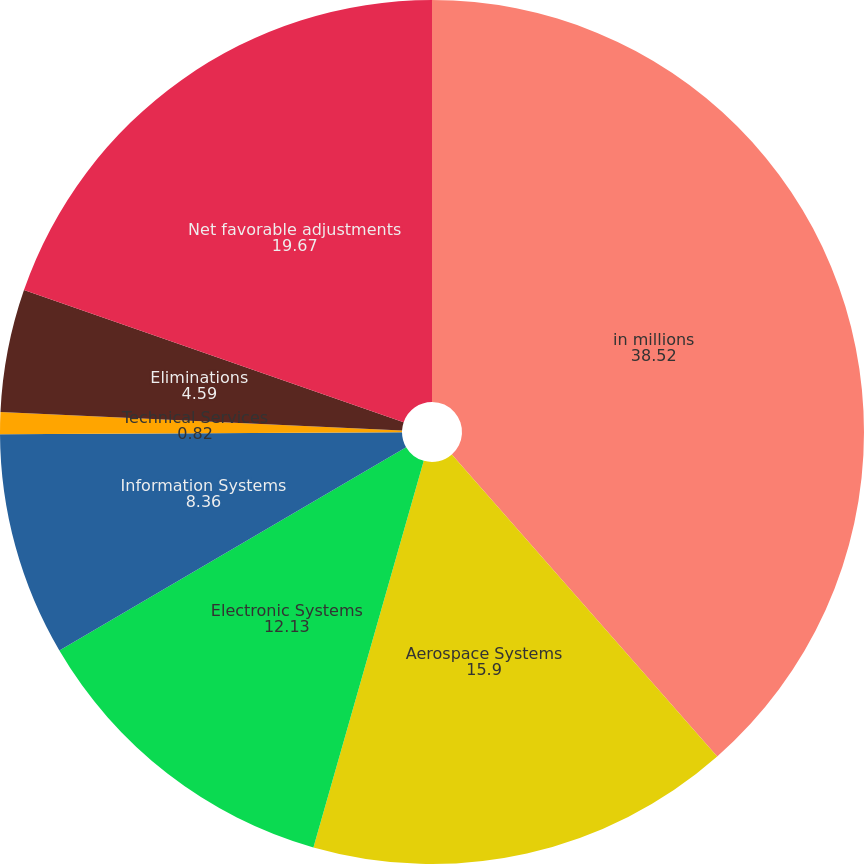Convert chart. <chart><loc_0><loc_0><loc_500><loc_500><pie_chart><fcel>in millions<fcel>Aerospace Systems<fcel>Electronic Systems<fcel>Information Systems<fcel>Technical Services<fcel>Eliminations<fcel>Net favorable adjustments<nl><fcel>38.52%<fcel>15.9%<fcel>12.13%<fcel>8.36%<fcel>0.82%<fcel>4.59%<fcel>19.67%<nl></chart> 